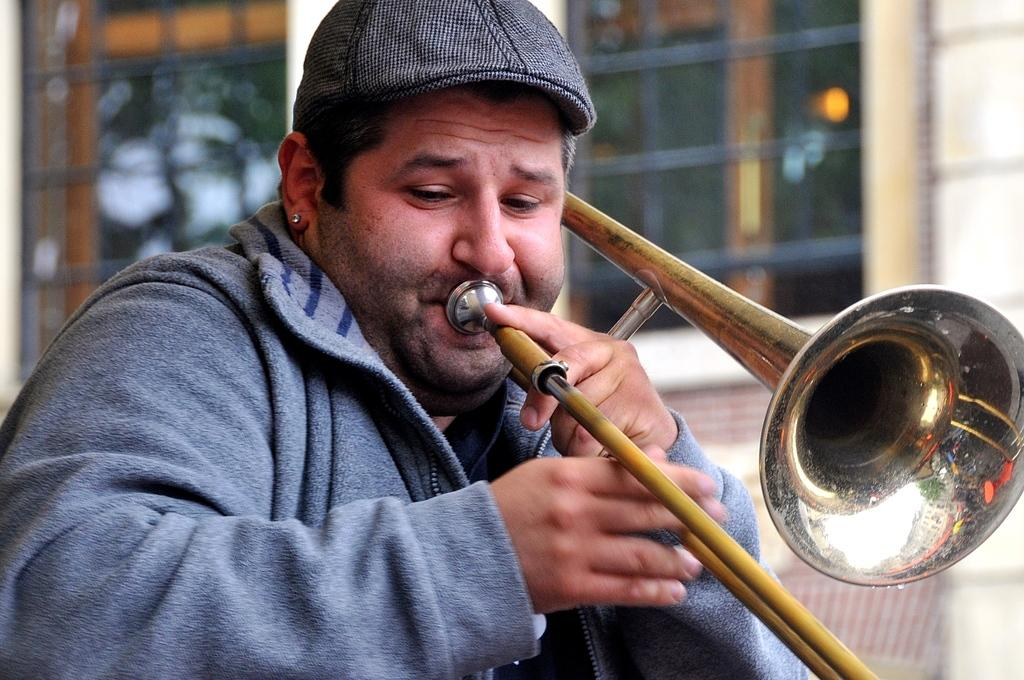What is the main subject of the image? There is a person in the image. What is the person doing in the image? The person is playing a musical instrument. What type of architectural feature can be seen in the image? There are glass windows visible in the image. Can you hear the person laughing while playing the musical instrument in the image? There is no sound in the image, so we cannot hear the person laughing or playing the musical instrument. 